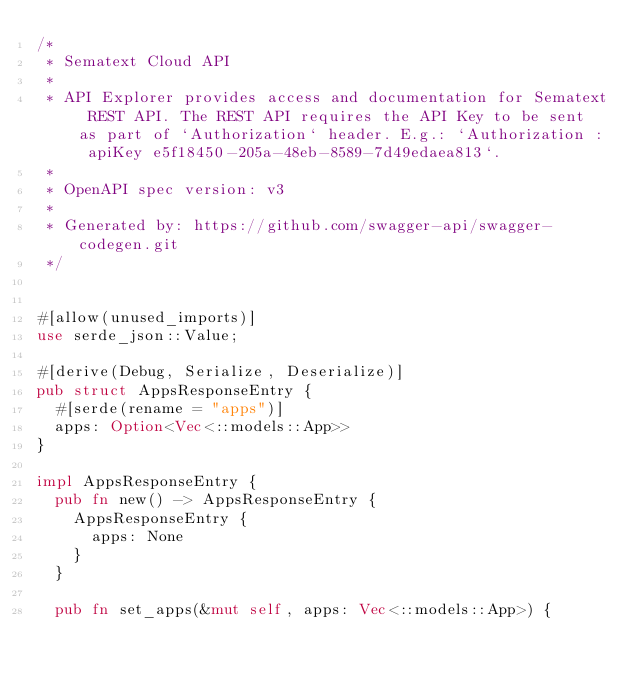Convert code to text. <code><loc_0><loc_0><loc_500><loc_500><_Rust_>/* 
 * Sematext Cloud API
 *
 * API Explorer provides access and documentation for Sematext REST API. The REST API requires the API Key to be sent as part of `Authorization` header. E.g.: `Authorization : apiKey e5f18450-205a-48eb-8589-7d49edaea813`.
 *
 * OpenAPI spec version: v3
 * 
 * Generated by: https://github.com/swagger-api/swagger-codegen.git
 */


#[allow(unused_imports)]
use serde_json::Value;

#[derive(Debug, Serialize, Deserialize)]
pub struct AppsResponseEntry {
  #[serde(rename = "apps")]
  apps: Option<Vec<::models::App>>
}

impl AppsResponseEntry {
  pub fn new() -> AppsResponseEntry {
    AppsResponseEntry {
      apps: None
    }
  }

  pub fn set_apps(&mut self, apps: Vec<::models::App>) {</code> 